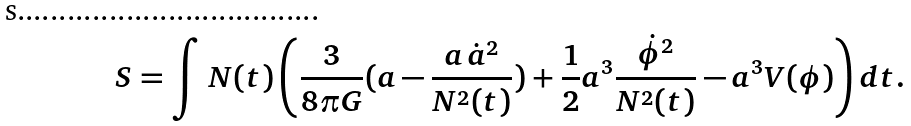<formula> <loc_0><loc_0><loc_500><loc_500>S = \int N ( t ) \left ( \frac { 3 } { 8 \pi G } ( a - \frac { a \, \dot { a } ^ { 2 } } { N ^ { 2 } ( t ) } ) + \frac { 1 } { 2 } a ^ { 3 } \frac { \dot { \phi } ^ { 2 } } { N ^ { 2 } ( t ) } - a ^ { 3 } V ( \phi ) \right ) d t .</formula> 